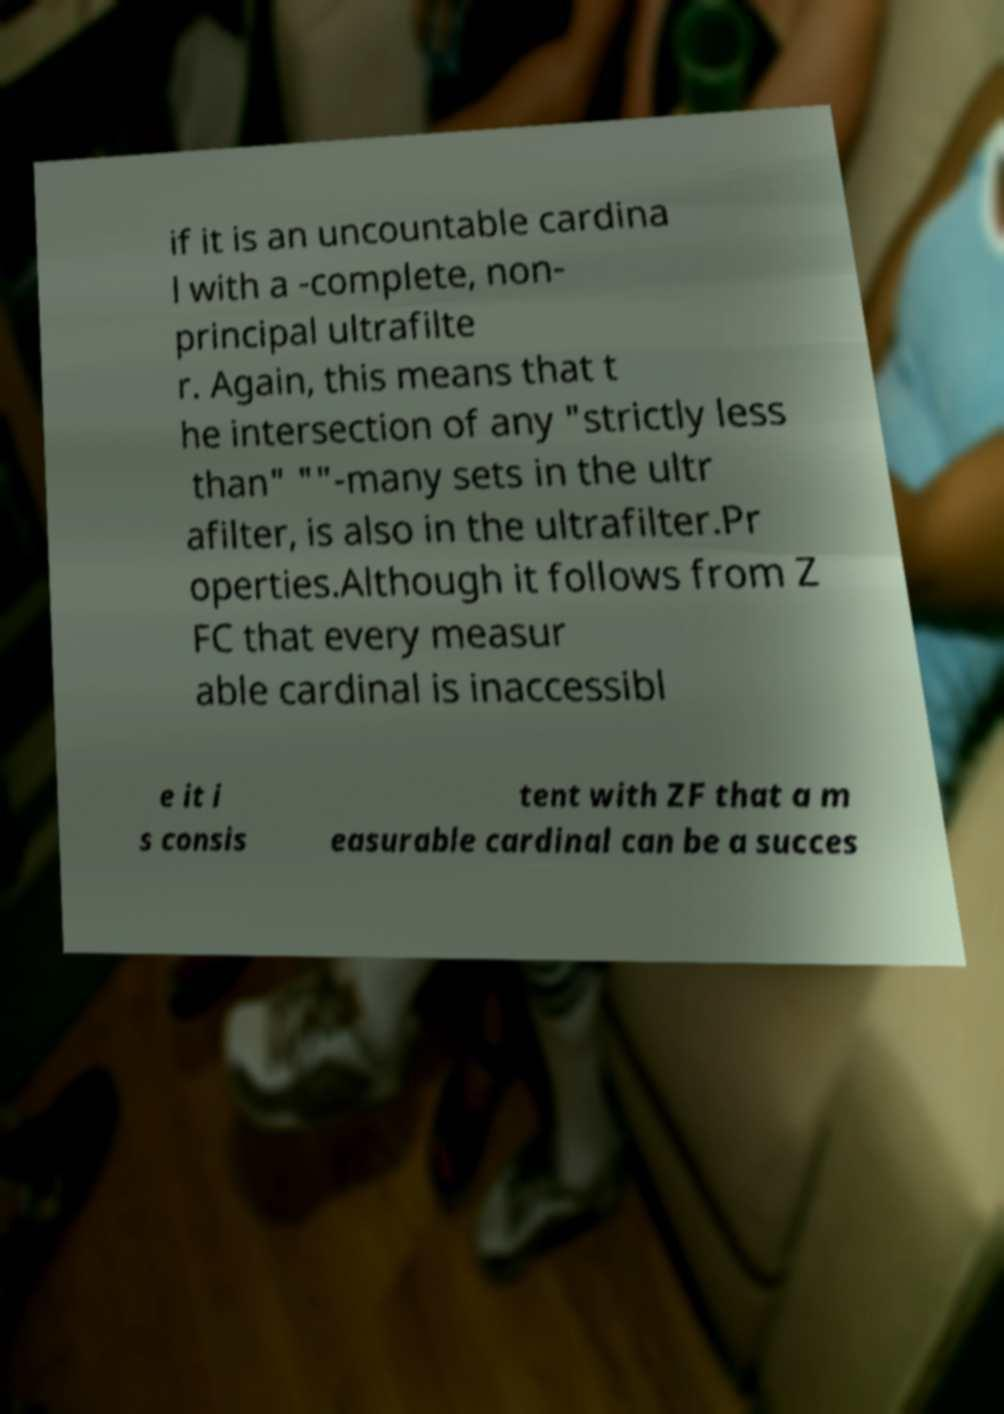Can you accurately transcribe the text from the provided image for me? if it is an uncountable cardina l with a -complete, non- principal ultrafilte r. Again, this means that t he intersection of any "strictly less than" ""-many sets in the ultr afilter, is also in the ultrafilter.Pr operties.Although it follows from Z FC that every measur able cardinal is inaccessibl e it i s consis tent with ZF that a m easurable cardinal can be a succes 